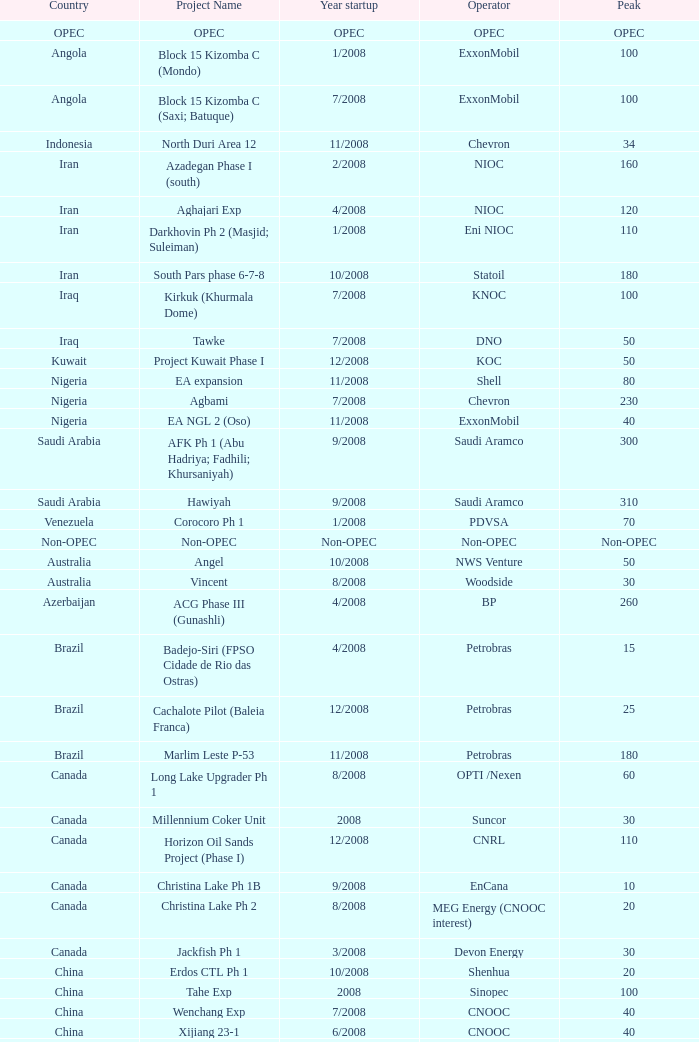What is the operator with a maximum of 55? PEMEX. 